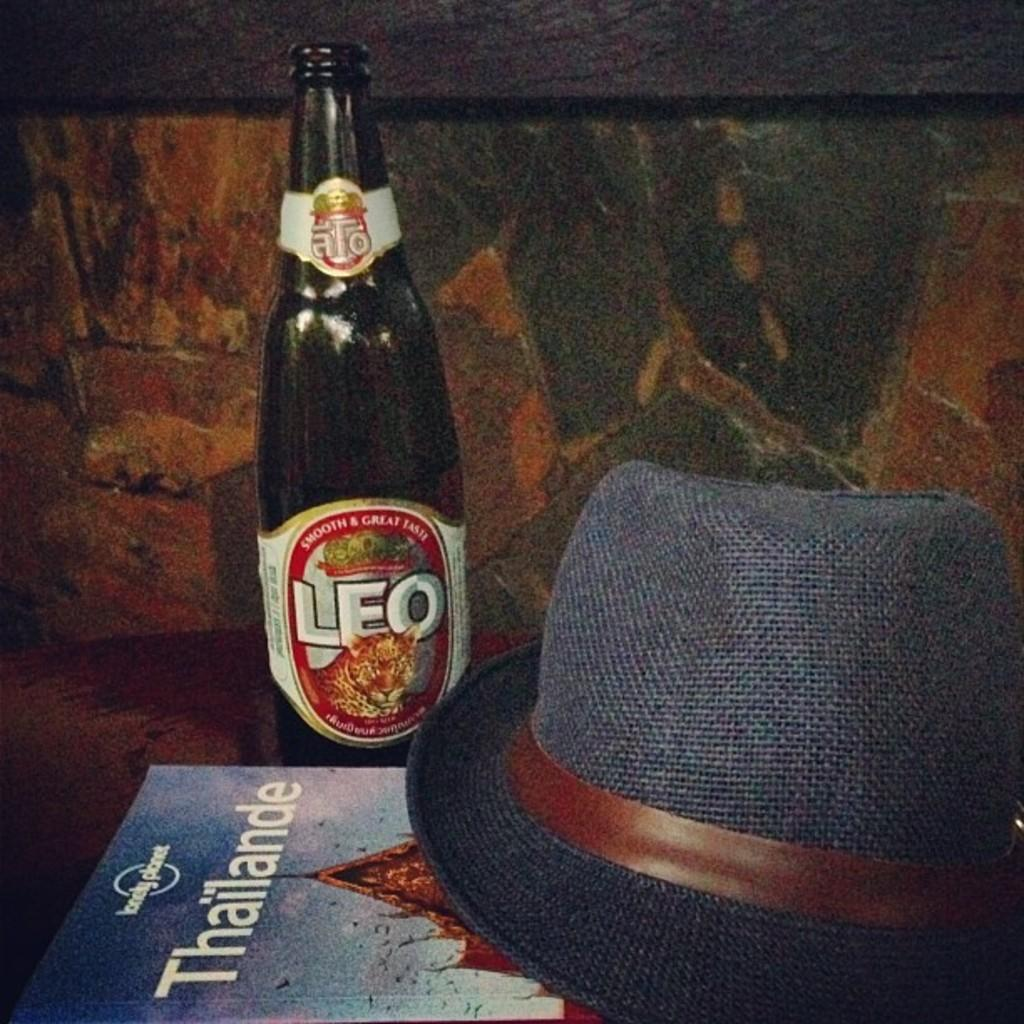What objects are in the foreground of the image? There is a hat, a poster, and a bottle in the foreground of the image. What can be seen in the background of the image? There appears to be a wall in the background of the image. What type of throat condition is depicted in the image? There is no depiction of a throat condition in the image; it features a hat, a poster, and a bottle in the foreground, and a wall in the background. What type of army is shown in the image? There is no depiction of an army in the image; it features a hat, a poster, and a bottle in the foreground, and a wall in the background. 